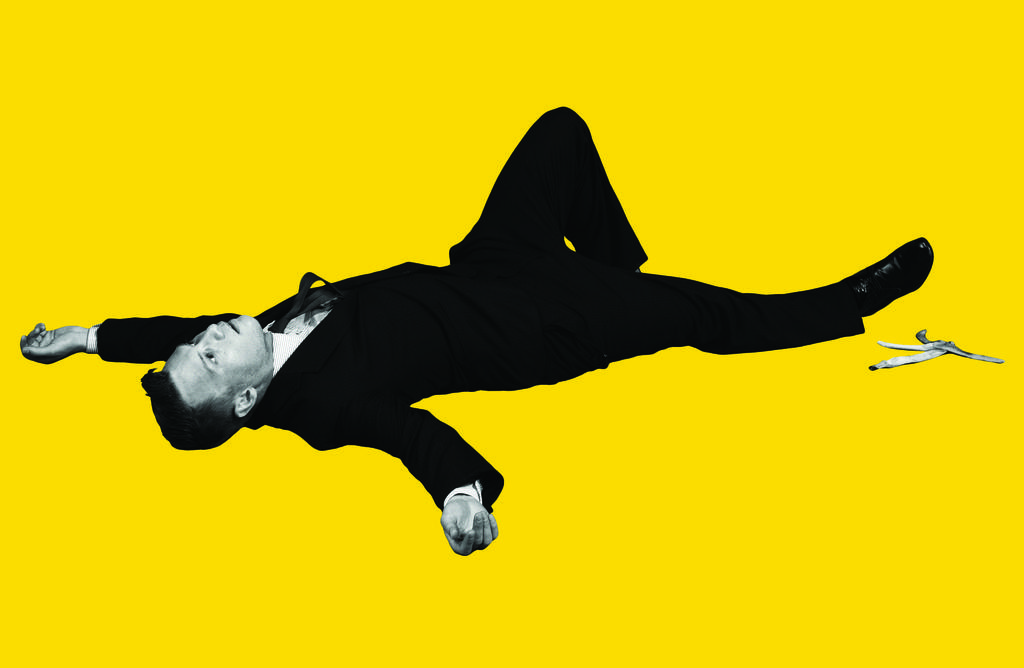What is the person in the image wearing? The person in the image is wearing a black suit. What object can be seen on the ground in the image? There is a banana peel in the image. What color is the background of the image? The background of the image is yellow. What type of respect can be seen in the image? There is no indication of respect in the image; it features a person wearing a black suit and a banana peel on the ground against a yellow background. 